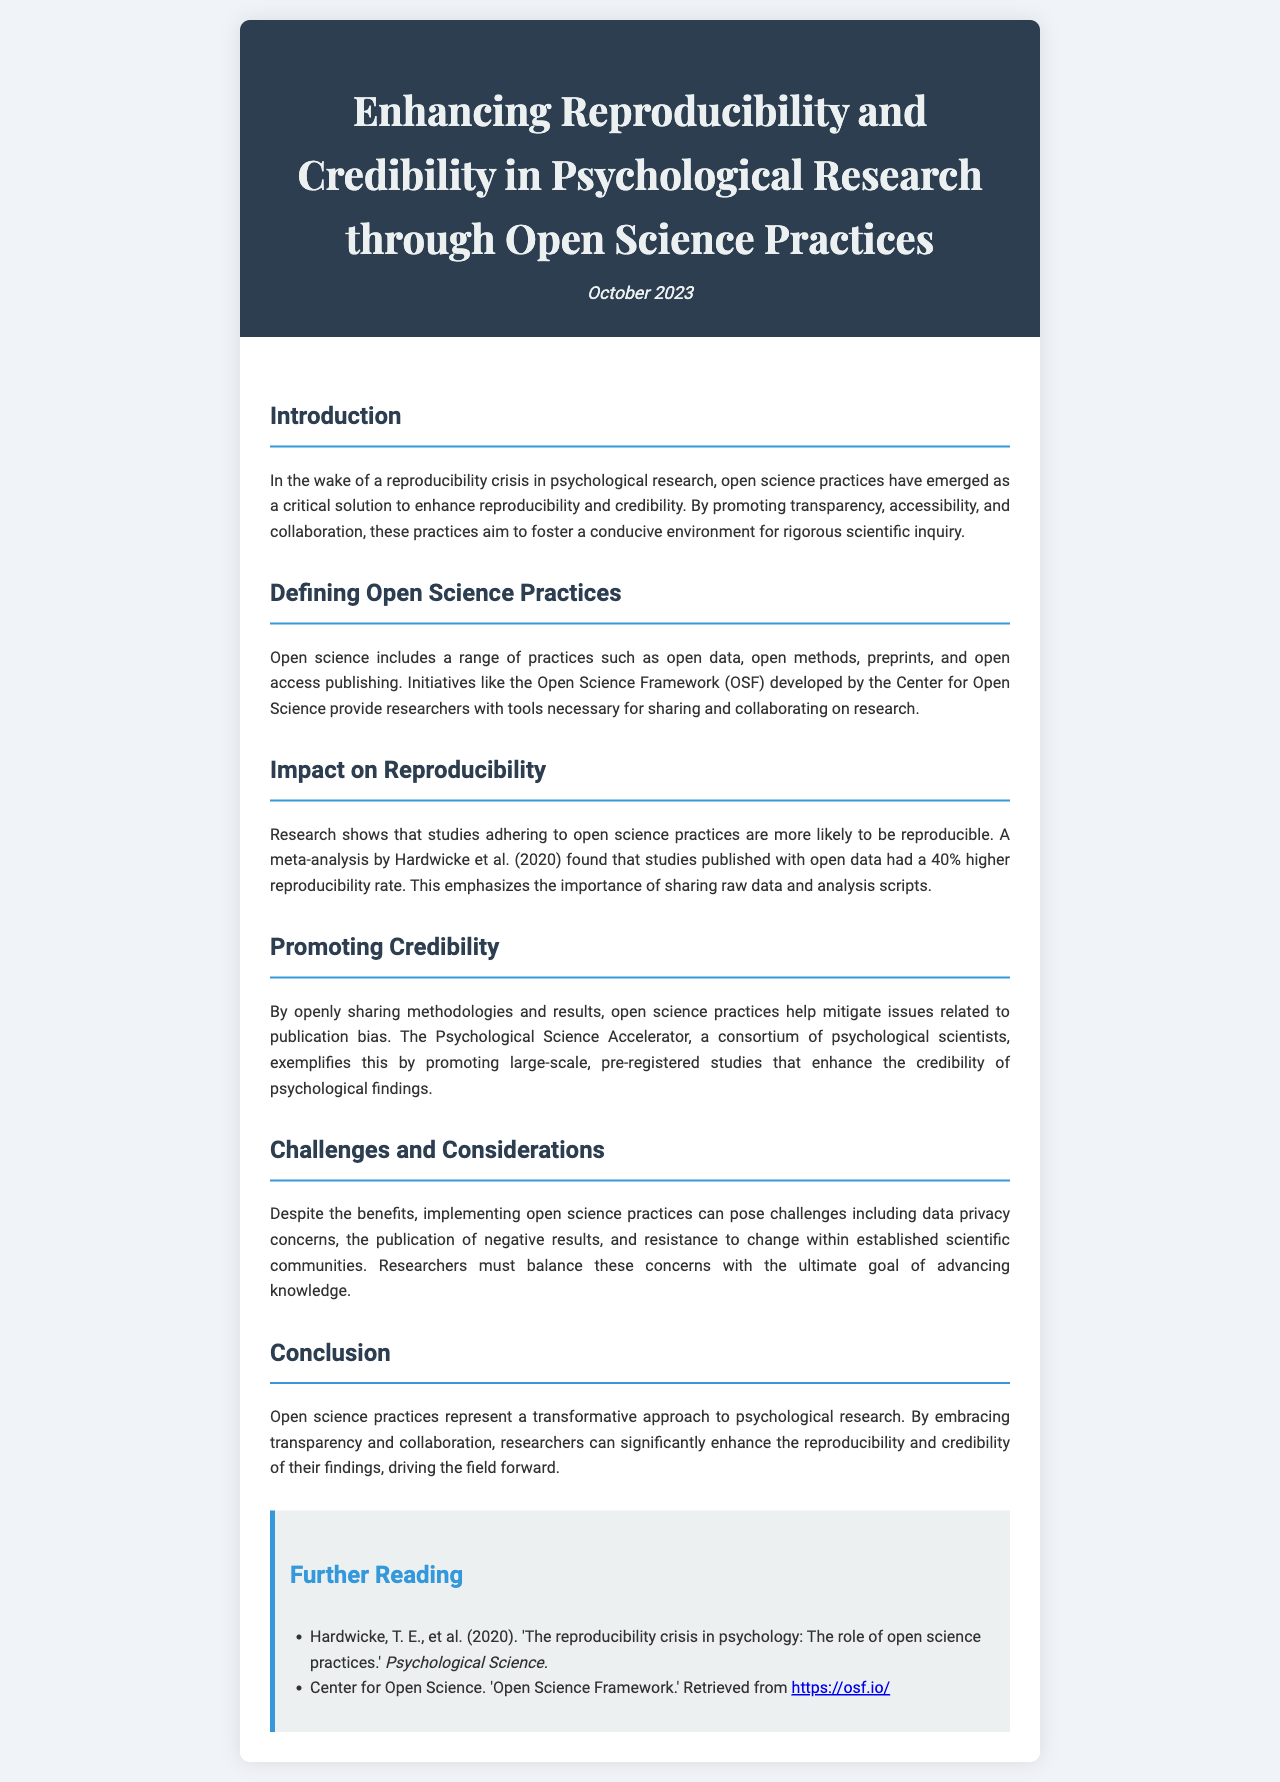What is the title of the newsletter? The title of the newsletter is stated prominently at the beginning of the document.
Answer: Enhancing Reproducibility and Credibility in Psychological Research through Open Science Practices What is the date of publication? The date of publication is clearly indicated in the header section of the newsletter.
Answer: October 2023 Which meta-analysis is mentioned regarding reproducibility rates? The meta-analysis is referenced in the section discussing the impact of open science on reproducibility.
Answer: Hardwicke et al. (2020) What is one of the initiatives mentioned that supports open science? The initiative is listed under the section defining open science practices as a tool for researchers.
Answer: Open Science Framework (OSF) What percentage higher is the reproducibility rate for studies published with open data? This percentage is provided in the impact on reproducibility section of the newsletter.
Answer: 40% What consortium is mentioned that promotes large-scale studies? The consortium is discussed in relation to enhancing credibility in psychological findings.
Answer: Psychological Science Accelerator What challenge related to open science practices is highlighted? The challenges faced in implementing open science practices are listed in a dedicated section.
Answer: Data privacy concerns What is the main focus of open science practices as discussed in the conclusion? The conclusion summarizes the overarching aim of the practices in the context of psychological research.
Answer: Transparency and collaboration 